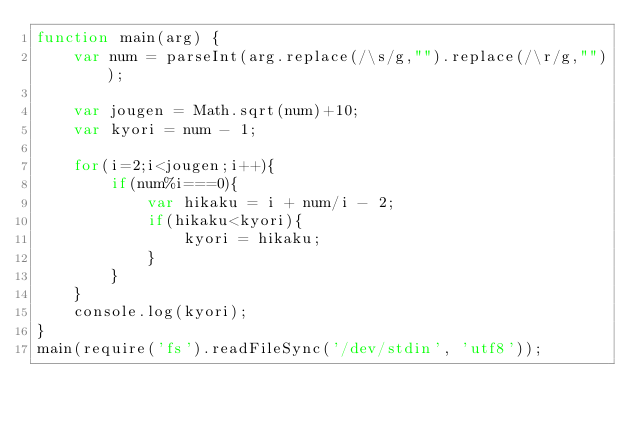Convert code to text. <code><loc_0><loc_0><loc_500><loc_500><_JavaScript_>function main(arg) {
	var num = parseInt(arg.replace(/\s/g,"").replace(/\r/g,""));
 
	var jougen = Math.sqrt(num)+10;
	var kyori = num - 1;
 
	for(i=2;i<jougen;i++){
		if(num%i===0){
			var hikaku = i + num/i - 2;
			if(hikaku<kyori){
				kyori = hikaku;
			}
		}
	}
	console.log(kyori);
}
main(require('fs').readFileSync('/dev/stdin', 'utf8'));</code> 